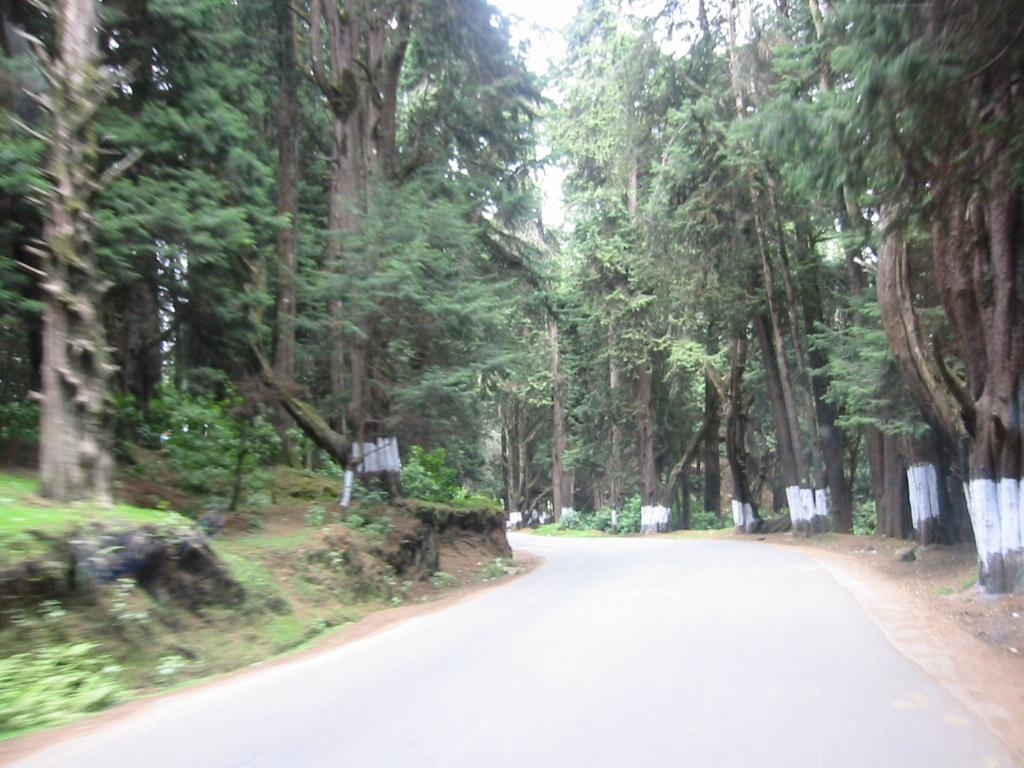What type of vegetation is present in the image? There are many trees, plants, and grass in the image. What is located at the bottom of the image? There is a road at the bottom of the image. What is visible at the top of the image? The sky is visible at the top of the image. Can you see a kite flying in the image? There is no kite present in the image. What type of work is being done in the image? The image does not depict any work being done; it primarily features natural elements like trees, plants, grass, and the sky. 